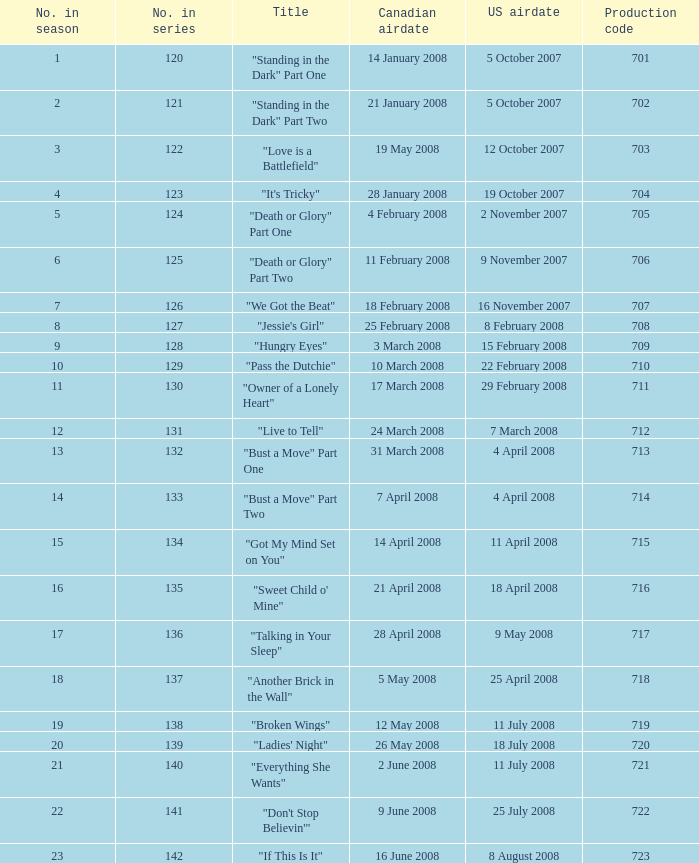The U.S. airdate of 8 august 2008 also had canadian airdates of what? 16 June 2008. 